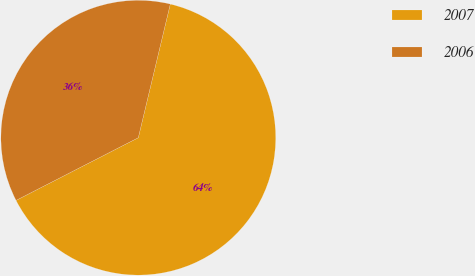Convert chart to OTSL. <chart><loc_0><loc_0><loc_500><loc_500><pie_chart><fcel>2007<fcel>2006<nl><fcel>63.72%<fcel>36.28%<nl></chart> 